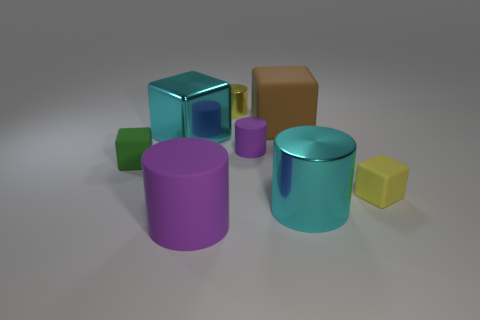Does the small metal cylinder have the same color as the tiny block that is to the right of the small shiny object?
Your answer should be compact. Yes. What is the color of the small matte thing that is the same shape as the small shiny thing?
Provide a short and direct response. Purple. There is a rubber cube on the right side of the brown block; is its size the same as the purple matte cylinder that is in front of the green matte object?
Make the answer very short. No. Is the large brown matte object the same shape as the big purple matte object?
Ensure brevity in your answer.  No. How many things are metallic objects that are to the right of the big purple rubber thing or small purple matte cylinders?
Your response must be concise. 3. Are there any other large rubber objects that have the same shape as the large brown matte thing?
Your answer should be compact. No. Are there the same number of purple rubber cylinders on the left side of the large metal cube and small yellow metallic objects?
Offer a terse response. No. There is a metallic thing that is the same color as the large metallic cylinder; what is its shape?
Provide a succinct answer. Cube. How many rubber cubes have the same size as the cyan metallic cube?
Offer a very short reply. 1. There is a cyan cylinder; what number of large purple matte cylinders are behind it?
Make the answer very short. 0. 